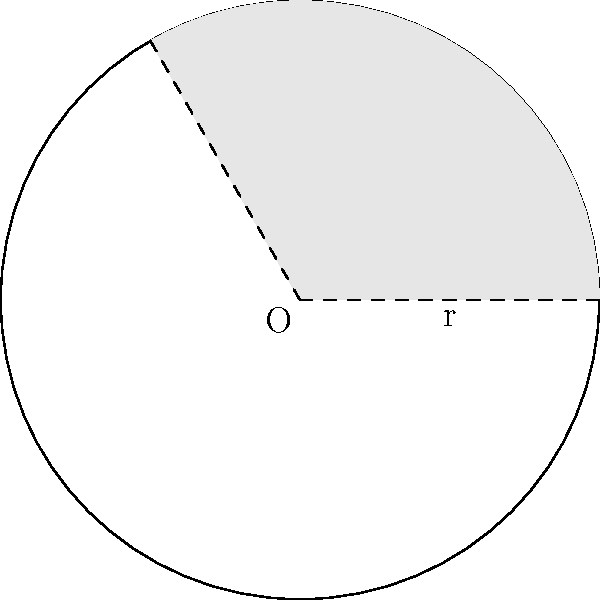In the circle shown above with center O and radius r, a sector is shaded. If the central angle of the sector is 120°, what fraction of the circle's area is shaded? Let's approach this step-by-step:

1) The area of a circle is given by the formula $A = \pi r^2$.

2) The area of a sector is proportional to its central angle. If the central angle is $\theta$ (in degrees), then the area of the sector is:

   $A_{sector} = \frac{\theta}{360°} \cdot \pi r^2$

3) In this case, $\theta = 120°$. So the area of the sector is:

   $A_{sector} = \frac{120°}{360°} \cdot \pi r^2 = \frac{1}{3} \cdot \pi r^2$

4) The fraction of the circle's area that is shaded is:

   $\frac{A_{sector}}{A_{circle}} = \frac{\frac{1}{3} \cdot \pi r^2}{\pi r^2} = \frac{1}{3}$

Therefore, one-third of the circle's area is shaded.
Answer: $\frac{1}{3}$ 